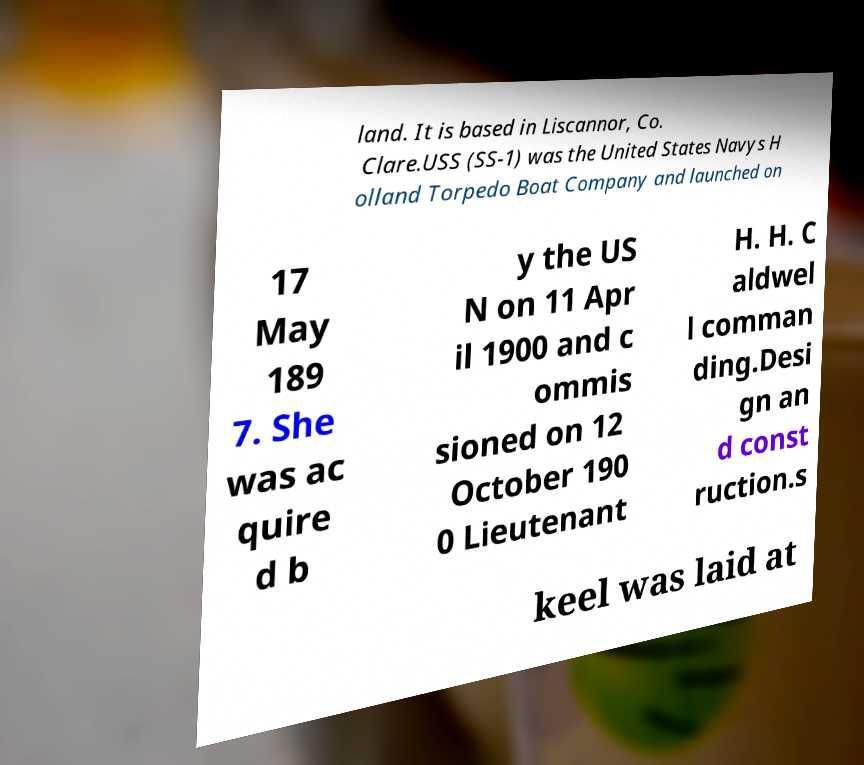Can you read and provide the text displayed in the image?This photo seems to have some interesting text. Can you extract and type it out for me? land. It is based in Liscannor, Co. Clare.USS (SS-1) was the United States Navys H olland Torpedo Boat Company and launched on 17 May 189 7. She was ac quire d b y the US N on 11 Apr il 1900 and c ommis sioned on 12 October 190 0 Lieutenant H. H. C aldwel l comman ding.Desi gn an d const ruction.s keel was laid at 